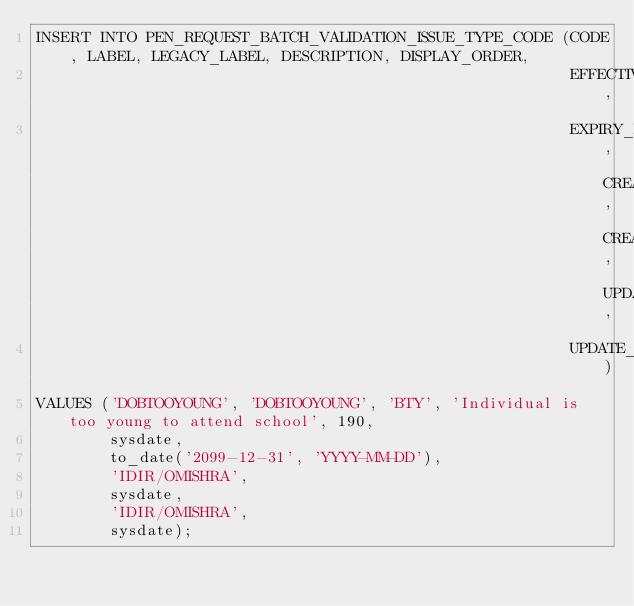<code> <loc_0><loc_0><loc_500><loc_500><_SQL_>INSERT INTO PEN_REQUEST_BATCH_VALIDATION_ISSUE_TYPE_CODE (CODE, LABEL, LEGACY_LABEL, DESCRIPTION, DISPLAY_ORDER,
                                                          EFFECTIVE_DATE,
                                                          EXPIRY_DATE, CREATE_USER, CREATE_DATE, UPDATE_USER,
                                                          UPDATE_DATE)
VALUES ('DOBTOOYOUNG', 'DOBTOOYOUNG', 'BTY', 'Individual is too young to attend school', 190,
        sysdate,
        to_date('2099-12-31', 'YYYY-MM-DD'),
        'IDIR/OMISHRA',
        sysdate,
        'IDIR/OMISHRA',
        sysdate);
</code> 